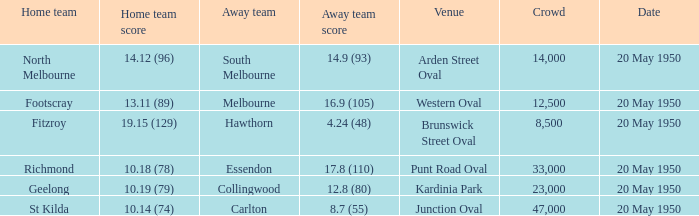What was the score for the away team when the home team was Fitzroy? 4.24 (48). 